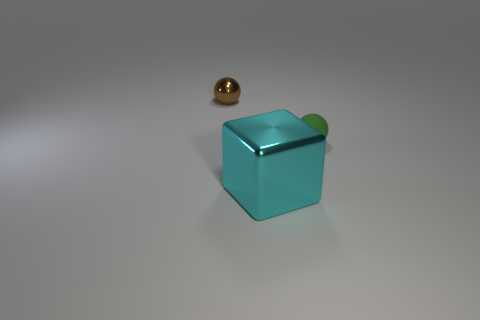Subtract all green spheres. How many spheres are left? 1 Subtract all blocks. How many objects are left? 2 Subtract 1 blocks. How many blocks are left? 0 Add 3 tiny gray cylinders. How many objects exist? 6 Subtract all blue cylinders. How many blue blocks are left? 0 Add 1 tiny purple cylinders. How many tiny purple cylinders exist? 1 Subtract 1 cyan blocks. How many objects are left? 2 Subtract all gray cubes. Subtract all red balls. How many cubes are left? 1 Subtract all green rubber spheres. Subtract all tiny red matte blocks. How many objects are left? 2 Add 2 small green things. How many small green things are left? 3 